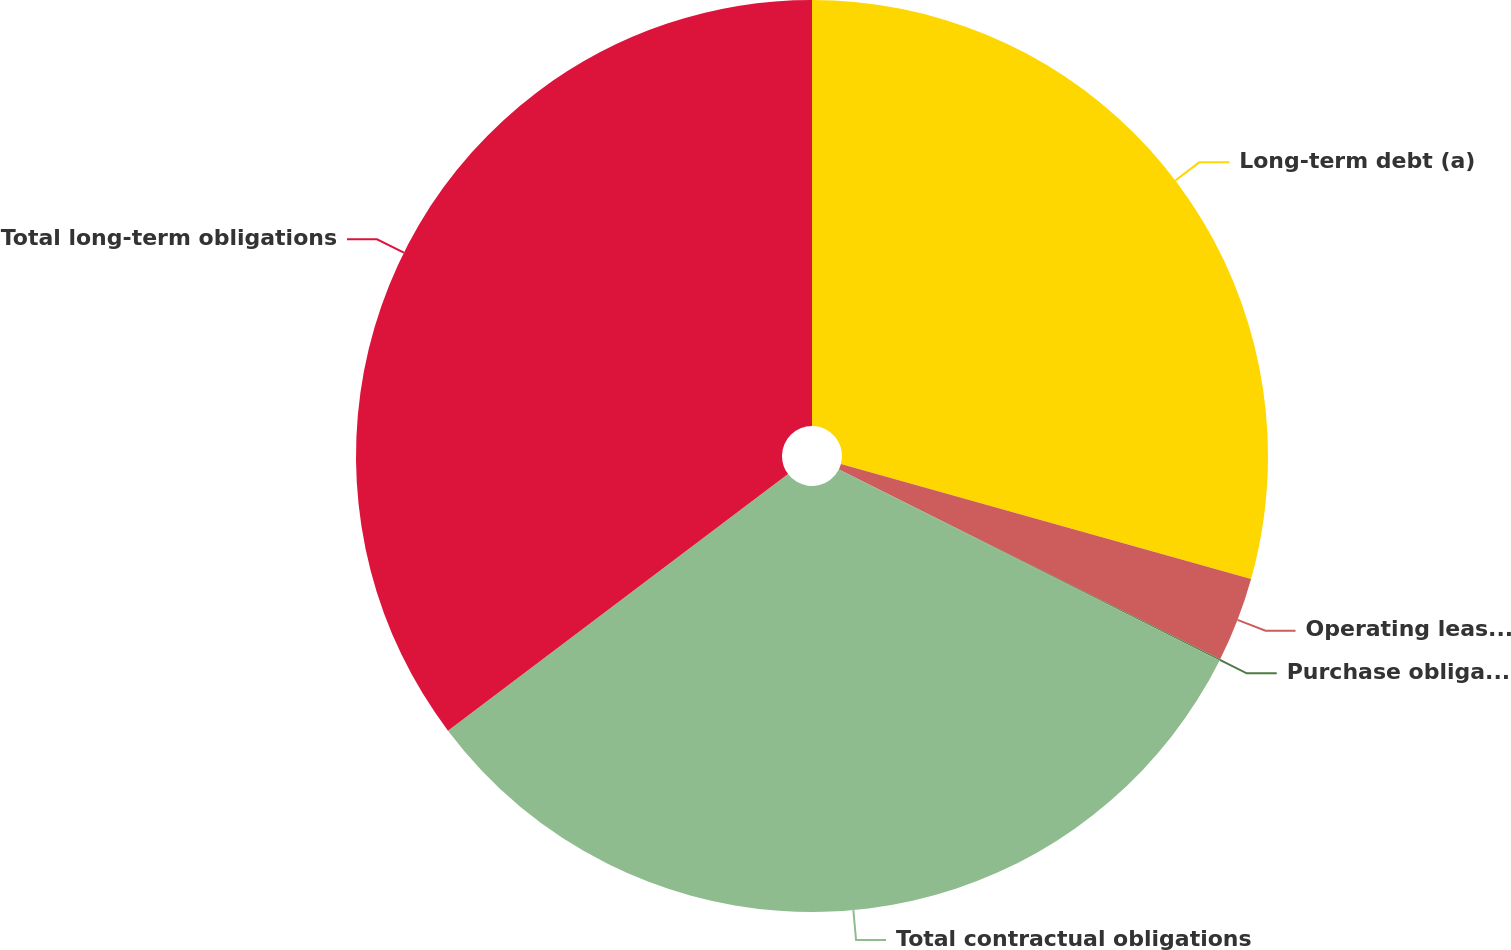<chart> <loc_0><loc_0><loc_500><loc_500><pie_chart><fcel>Long-term debt (a)<fcel>Operating leases (b)<fcel>Purchase obligations (c)<fcel>Total contractual obligations<fcel>Total long-term obligations<nl><fcel>29.35%<fcel>3.01%<fcel>0.04%<fcel>32.32%<fcel>35.29%<nl></chart> 